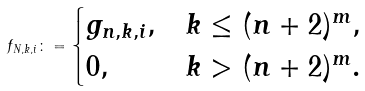Convert formula to latex. <formula><loc_0><loc_0><loc_500><loc_500>f _ { N , k , i } \colon = \begin{cases} g _ { n , k , i } , & k \leq ( n + 2 ) ^ { m } , \\ 0 , & k > ( n + 2 ) ^ { m } . \end{cases}</formula> 